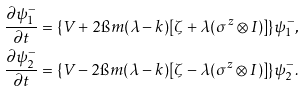Convert formula to latex. <formula><loc_0><loc_0><loc_500><loc_500>& \frac { \partial \psi ^ { - } _ { 1 } } { \partial t } = \{ V + 2 \i m ( \lambda - k ) [ \zeta + \lambda ( \sigma ^ { z } \otimes I ) ] \} \psi ^ { - } _ { 1 } , \\ & \frac { \partial \psi ^ { - } _ { 2 } } { \partial t } = \{ V - 2 \i m ( \lambda - k ) [ \zeta - \lambda ( \sigma ^ { z } \otimes I ) ] \} \psi ^ { - } _ { 2 } .</formula> 